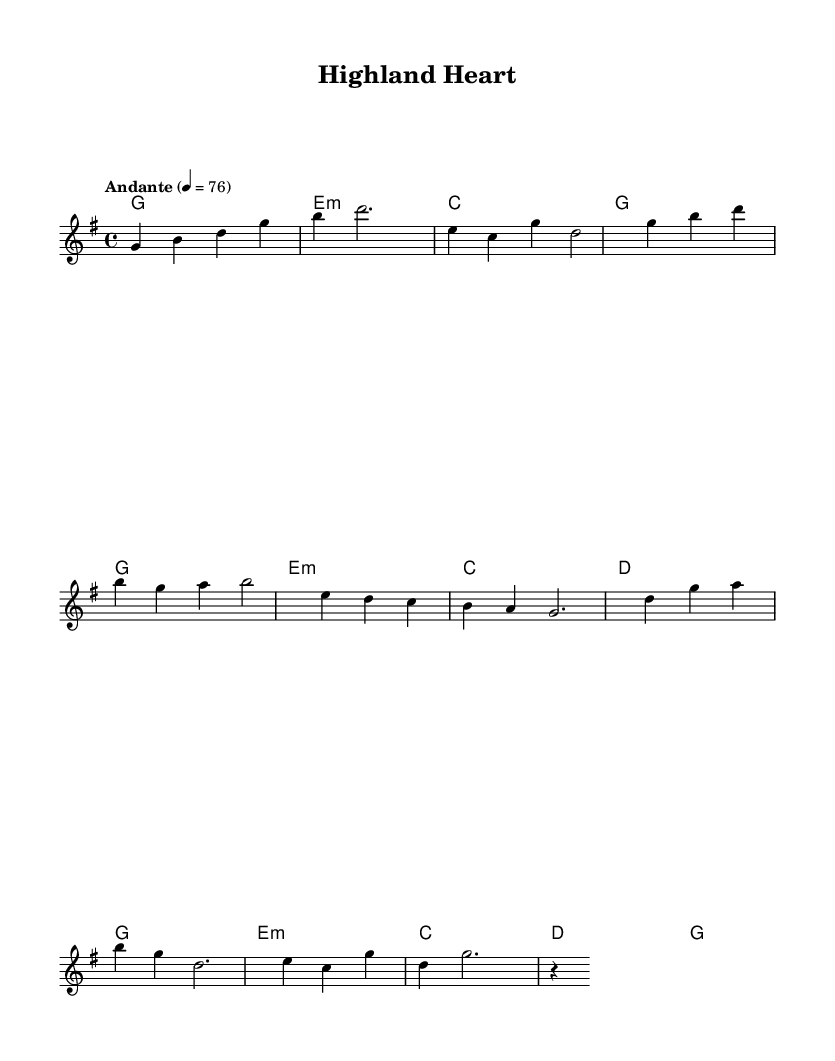What is the key signature of this music? The key signature is G major, which has one sharp. You can tell by looking at the key signature at the beginning of the staff.
Answer: G major What is the time signature of this piece? The time signature is 4/4, indicated at the beginning of the music. This means there are four beats in each measure, and the quarter note gets one beat.
Answer: 4/4 What is the tempo marking of this piece? The tempo marking is "Andante," which indicates a moderately slow tempo. It is also quantified with "4 = 76," meaning a quarter note is played at 76 beats per minute.
Answer: Andante What chords are used in the chorus? The chords used in the chorus are G, E minor, C, D, and G. You can find these chords listed in the harmonies section corresponding to the measures where the chorus occurs.
Answer: G, E minor, C, D, G How many measures are in the intro? The intro consists of two measures as identified by the grouping of the notes and the absence of additional repeats or constructions within the section.
Answer: 2 What is a unique aspect of this music that relates to its K-Pop influence? A unique aspect is the blend of modern K-Pop ballad structures with traditional folk motifs, evident in the melodic style and flowing harmonies reminiscent of Scottish folk music. This characteristic is particularly notable in the melody.
Answer: Blend of K-Pop and Scottish folk What is the rhythmic feel created by the 4/4 time signature in this piece? The 4/4 time signature creates a stable, straightforward rhythmic feel, which is common in both ballads and K-Pop, allowing for expressive and emotional phrasing throughout the melody.
Answer: Stable and straightforward 